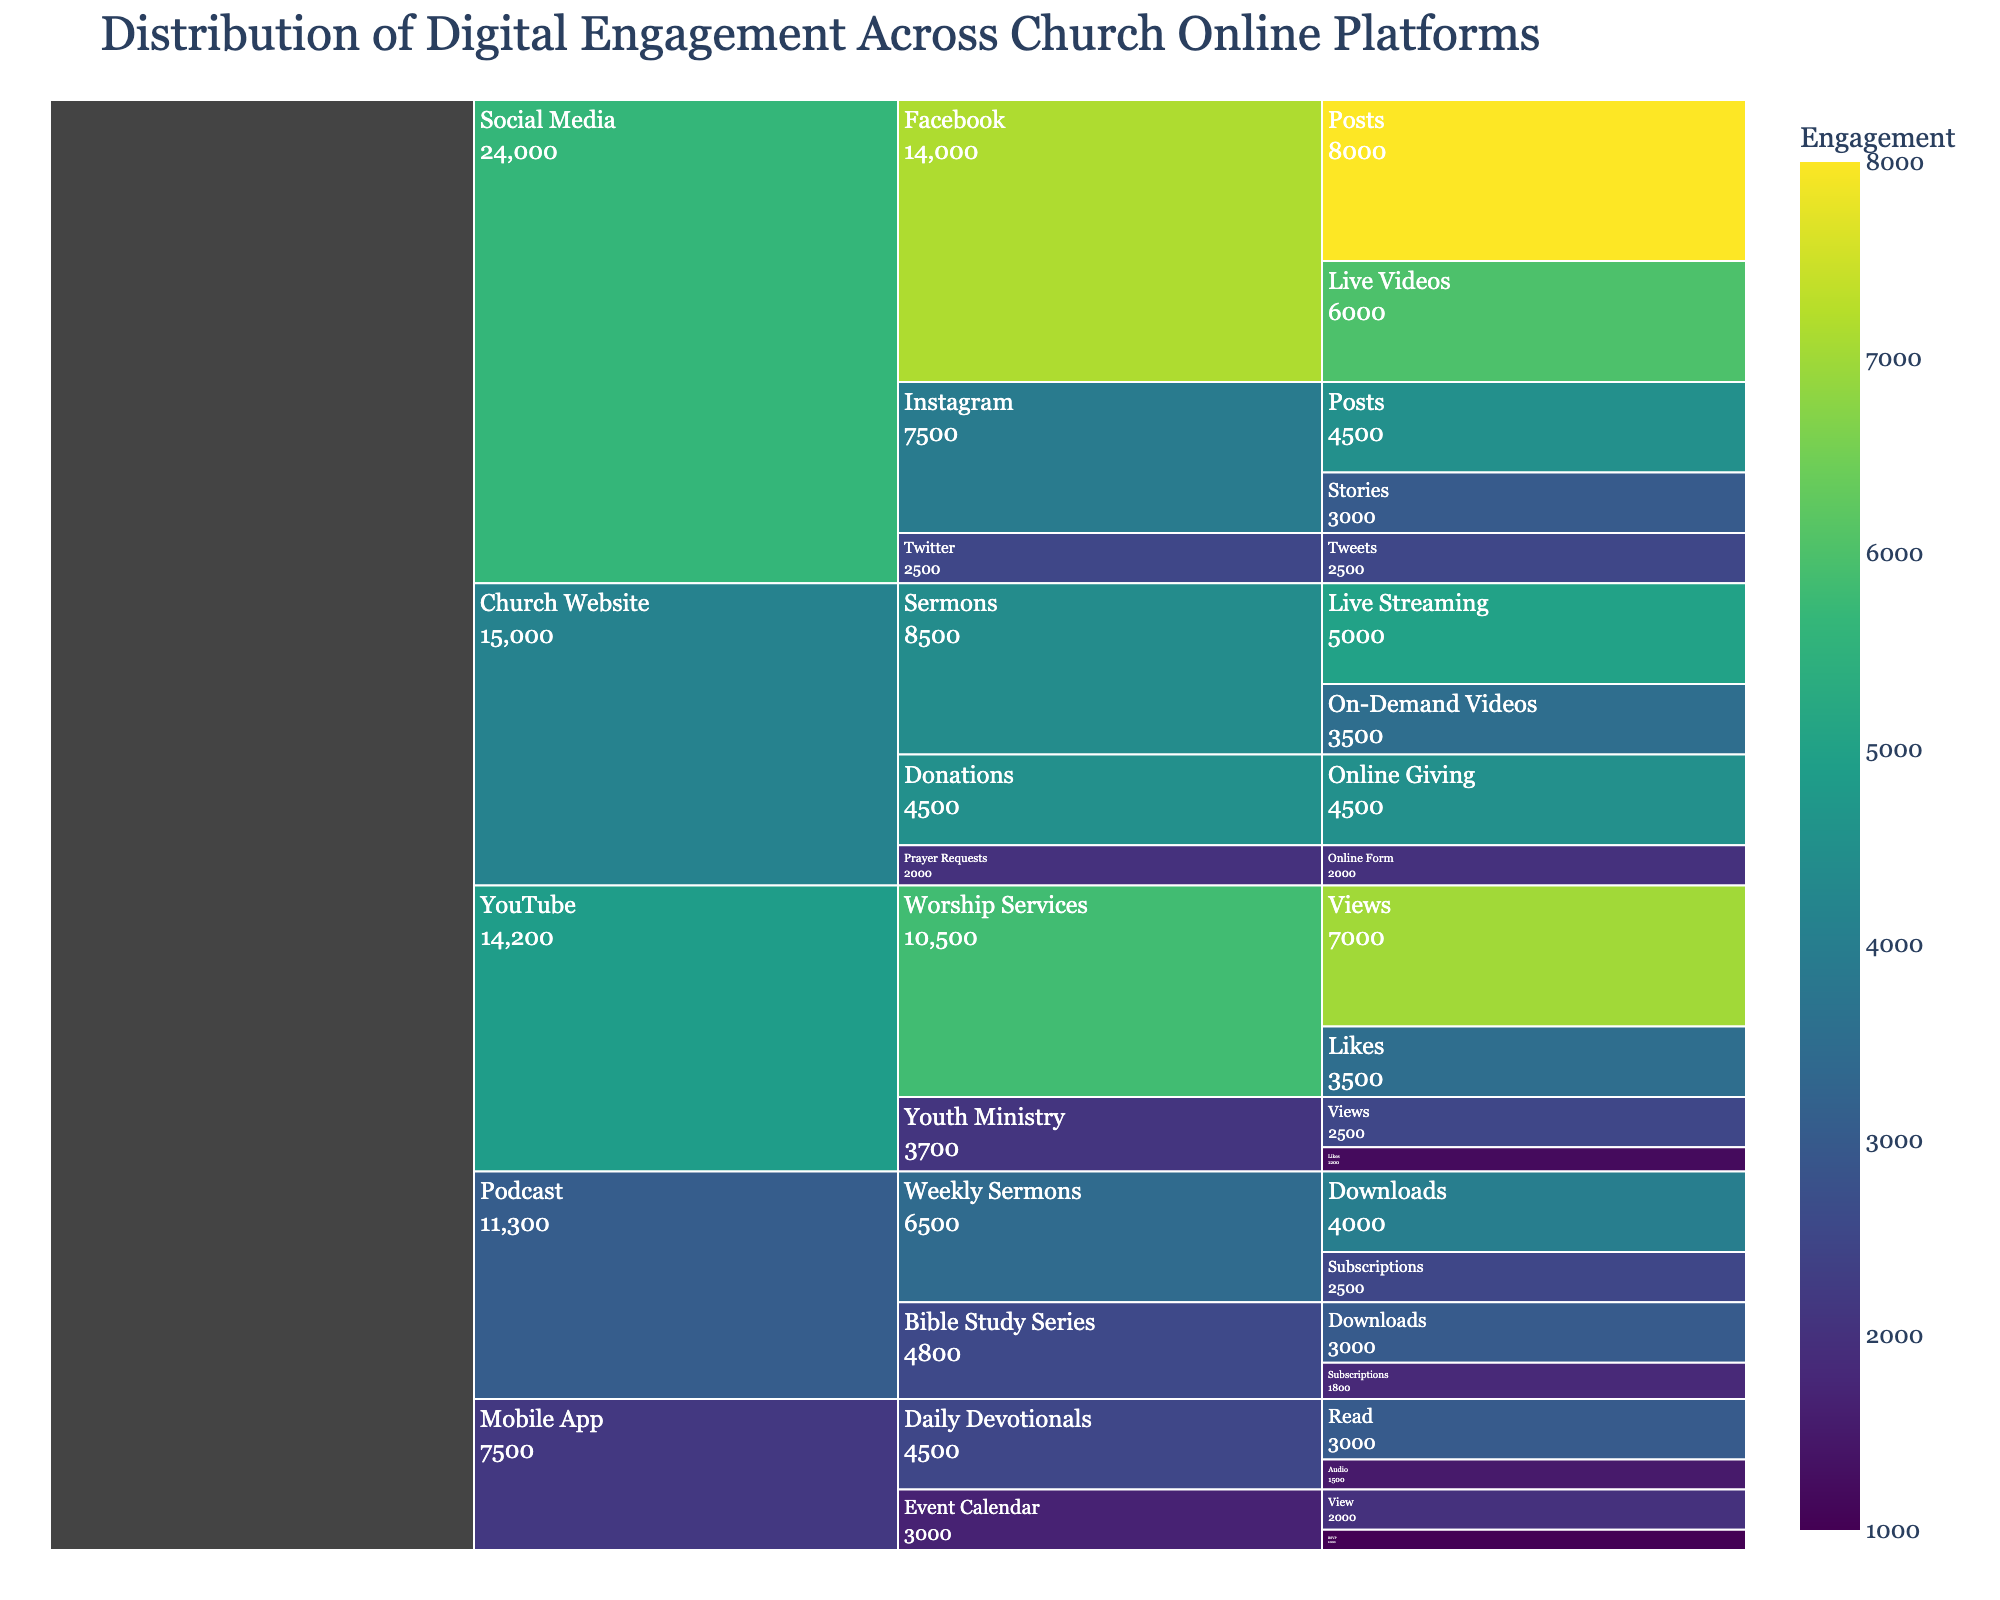What are the main platforms described in the chart? The main platforms are the first level in the hierarchy. They include Church Website, Social Media, Mobile App, Podcast, and YouTube.
Answer: Church Website, Social Media, Mobile App, Podcast, YouTube Which platform has the highest total digital engagement? By examining the chart, the platform with the highest cumulative engagement value can be identified. Social Media shows the highest engagement as it has tall pillars representing large values.
Answer: Social Media What's the total engagement for Church Website across all categories? Summing the engagement values for all subcategories under Church Website: (5000 + 3500 + 2000 + 4500) = 15000.
Answer: 15000 What is the digital engagement for Live Streaming on the Church Website? By looking at the Church Website section and then narrowing down to Sermons, we find Live Streaming with an engagement of 5000.
Answer: 5000 Compare the engagement of Facebook Posts and Instagram Posts under Social Media. Which one is higher? Facebook Posts engagement is 8000, while Instagram Posts engagement is 4500. 8000 is greater than 4500, so Facebook Posts have higher engagement.
Answer: Facebook Posts Which subcategory under Mobile App has the least engagement and what is its value? Under Mobile App, comparing the engagements of Daily Devotionals and Event Calendar, RSVP has the least with a value of 1000.
Answer: RSVP, 1000 Calculate the total engagement for Worship Services on YouTube. Summing the two subcategories: (7000 for Views + 3500 for Likes) = 10500.
Answer: 10500 How does the engagement for Weekly Sermons on Podcast compare to that of Bible Study Series on Podcast? Weekly Sermons total (Downloads + Subscriptions) is 6500 (4000 + 2500), while Bible Study Series total is 4800 (3000 + 1800). 6500 is greater than 4800.
Answer: Weekly Sermons is higher Which category under YouTube has higher engagement: Worship Services or Youth Ministry? By adding up Views and Likes for both categories, Worship Services (10500) and Youth Ministry (3700). Comparing the two, 10500 is higher than 3700.
Answer: Worship Services What is the total engagement for all platforms combined? By summing engagement values across all data points provided, total is: 5000 + 3500 + 2000 + 4500 + 8000 + 6000 + 4500 + 3000 + 2500 + 3000 + 1500 + 2000 + 1000 + 4000 + 2500 + 3000 + 1800 + 7000 + 3500 + 2500 + 1200 = 72800.
Answer: 72800 